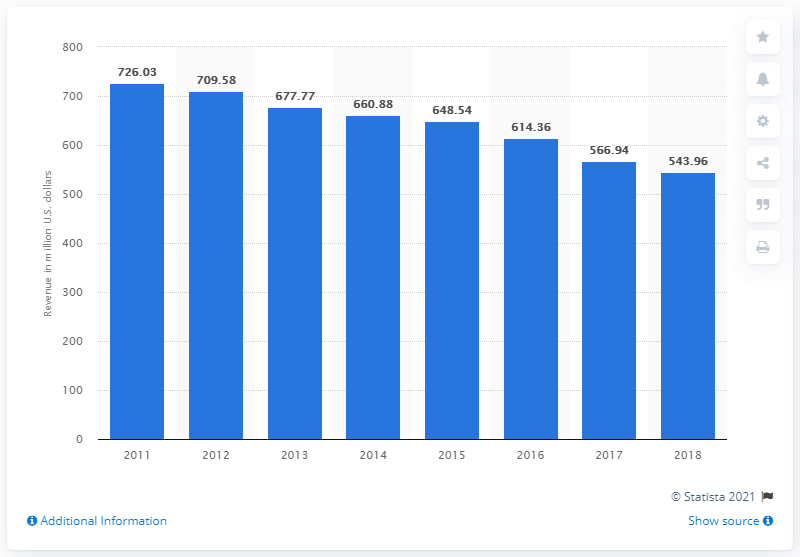List a handful of essential elements in this visual. In 2018, Lee Enterprises generated a total revenue of 543.96. 